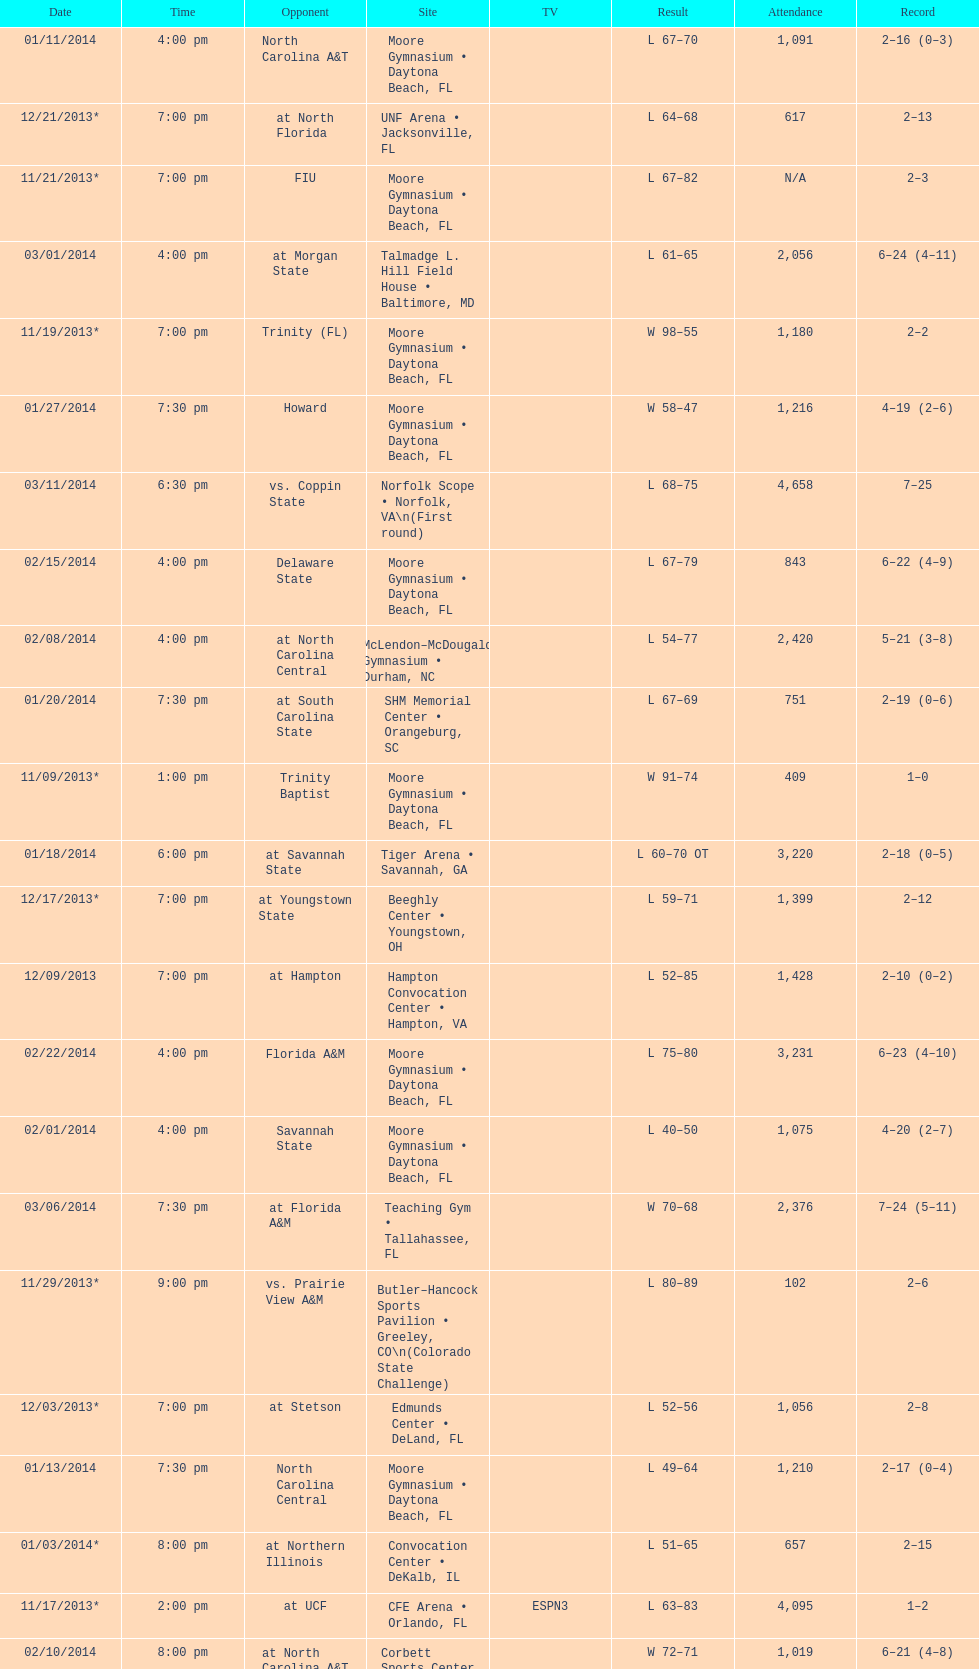Parse the table in full. {'header': ['Date', 'Time', 'Opponent', 'Site', 'TV', 'Result', 'Attendance', 'Record'], 'rows': [['01/11/2014', '4:00 pm', 'North Carolina A&T', 'Moore Gymnasium • Daytona Beach, FL', '', 'L\xa067–70', '1,091', '2–16 (0–3)'], ['12/21/2013*', '7:00 pm', 'at\xa0North Florida', 'UNF Arena • Jacksonville, FL', '', 'L\xa064–68', '617', '2–13'], ['11/21/2013*', '7:00 pm', 'FIU', 'Moore Gymnasium • Daytona Beach, FL', '', 'L\xa067–82', 'N/A', '2–3'], ['03/01/2014', '4:00 pm', 'at\xa0Morgan State', 'Talmadge L. Hill Field House • Baltimore, MD', '', 'L\xa061–65', '2,056', '6–24 (4–11)'], ['11/19/2013*', '7:00 pm', 'Trinity (FL)', 'Moore Gymnasium • Daytona Beach, FL', '', 'W\xa098–55', '1,180', '2–2'], ['01/27/2014', '7:30 pm', 'Howard', 'Moore Gymnasium • Daytona Beach, FL', '', 'W\xa058–47', '1,216', '4–19 (2–6)'], ['03/11/2014', '6:30 pm', 'vs.\xa0Coppin State', 'Norfolk Scope • Norfolk, VA\\n(First round)', '', 'L\xa068–75', '4,658', '7–25'], ['02/15/2014', '4:00 pm', 'Delaware State', 'Moore Gymnasium • Daytona Beach, FL', '', 'L\xa067–79', '843', '6–22 (4–9)'], ['02/08/2014', '4:00 pm', 'at\xa0North Carolina Central', 'McLendon–McDougald Gymnasium • Durham, NC', '', 'L\xa054–77', '2,420', '5–21 (3–8)'], ['01/20/2014', '7:30 pm', 'at\xa0South Carolina State', 'SHM Memorial Center • Orangeburg, SC', '', 'L\xa067–69', '751', '2–19 (0–6)'], ['11/09/2013*', '1:00 pm', 'Trinity Baptist', 'Moore Gymnasium • Daytona Beach, FL', '', 'W\xa091–74', '409', '1–0'], ['01/18/2014', '6:00 pm', 'at\xa0Savannah State', 'Tiger Arena • Savannah, GA', '', 'L\xa060–70\xa0OT', '3,220', '2–18 (0–5)'], ['12/17/2013*', '7:00 pm', 'at\xa0Youngstown State', 'Beeghly Center • Youngstown, OH', '', 'L\xa059–71', '1,399', '2–12'], ['12/09/2013', '7:00 pm', 'at\xa0Hampton', 'Hampton Convocation Center • Hampton, VA', '', 'L\xa052–85', '1,428', '2–10 (0–2)'], ['02/22/2014', '4:00 pm', 'Florida A&M', 'Moore Gymnasium • Daytona Beach, FL', '', 'L\xa075–80', '3,231', '6–23 (4–10)'], ['02/01/2014', '4:00 pm', 'Savannah State', 'Moore Gymnasium • Daytona Beach, FL', '', 'L\xa040–50', '1,075', '4–20 (2–7)'], ['03/06/2014', '7:30 pm', 'at\xa0Florida A&M', 'Teaching Gym • Tallahassee, FL', '', 'W\xa070–68', '2,376', '7–24 (5–11)'], ['11/29/2013*', '9:00 pm', 'vs.\xa0Prairie View A&M', 'Butler–Hancock Sports Pavilion • Greeley, CO\\n(Colorado State Challenge)', '', 'L\xa080–89', '102', '2–6'], ['12/03/2013*', '7:00 pm', 'at\xa0Stetson', 'Edmunds Center • DeLand, FL', '', 'L\xa052–56', '1,056', '2–8'], ['01/13/2014', '7:30 pm', 'North Carolina Central', 'Moore Gymnasium • Daytona Beach, FL', '', 'L\xa049–64', '1,210', '2–17 (0–4)'], ['01/03/2014*', '8:00 pm', 'at\xa0Northern Illinois', 'Convocation Center • DeKalb, IL', '', 'L\xa051–65', '657', '2–15'], ['11/17/2013*', '2:00 pm', 'at\xa0UCF', 'CFE Arena • Orlando, FL', 'ESPN3', 'L\xa063–83', '4,095', '1–2'], ['02/10/2014', '8:00 pm', 'at\xa0North Carolina A&T', 'Corbett Sports Center • Greensboro, NC', '', 'W\xa072–71', '1,019', '6–21 (4–8)'], ['12/14/2013*', '4:00 pm', 'at\xa0Akron', 'James A. Rhodes Arena • Akron, OH', '', 'L\xa056–84', '2,763', '2–11'], ['01/25/2014', '4:00 pm', 'Maryland Eastern Shore', 'Moore Gymnasium • Daytona Beach, FL', '', 'W\xa069–63', '1,030', '3–19 (1–6)'], ['02/03/2014', '7:30 pm', 'South Carolina State', 'Moore Gymnasium • Daytona Beach, FL', '', 'W\xa091–59', '1,063', '5–20 (3–7)'], ['11/27/2013*', '4:00 pm', 'at\xa0New Mexico State', 'Moby Arena • Fort Collins, CO\\n(Colorado State Challenge)', '', 'L\xa052–66', '2,945', '2–5'], ['12/07/2013', '6:00 pm', 'at\xa0Norfolk State', 'Joseph G. Echols Memorial Hall • Norfolk, VA', '', 'L\xa045–59', '1,425', '2–9 (0–1)'], ['12/30/2013*', '8:00 pm', 'at\xa0Detroit', 'Calihan Hall • Detroit, MI', '', 'L\xa053–73', '3,107', '2–14'], ['11/25/2013*', '9:00 pm', 'at\xa0New Mexico State', 'Pan American Center • Las Cruces, NM\\n(Colorado State Challenge)', '', 'L\xa056–79', '4,985', '2–4'], ['11/30/2013*', '9:00 pm', 'at\xa0Northern Colorado', 'Butler–Hancock Sports Pavilion • Greeley, CO\\n(Colorado State Challenge)', '', 'L\xa060–65', 'N/A', '2–7'], ['11/12/2013*', '7:00 pm', 'at\xa0South Florida', 'USF Sun Dome • Tampa, FL', 'ESPN3', 'L\xa065–91', '3,549', '1–1']]} How many teams had at most an attendance of 1,000? 6. 